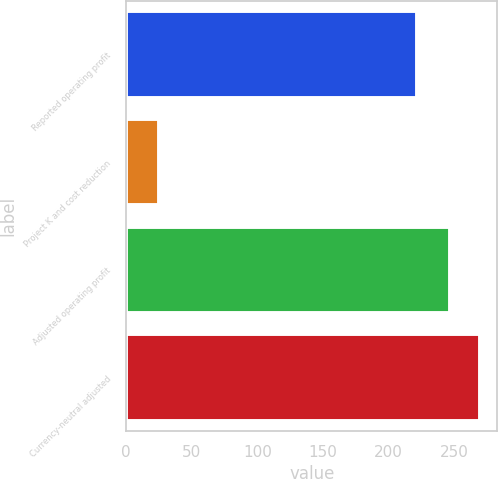Convert chart. <chart><loc_0><loc_0><loc_500><loc_500><bar_chart><fcel>Reported operating profit<fcel>Project K and cost reduction<fcel>Adjusted operating profit<fcel>Currency-neutral adjusted<nl><fcel>222<fcel>25<fcel>247<fcel>269.4<nl></chart> 